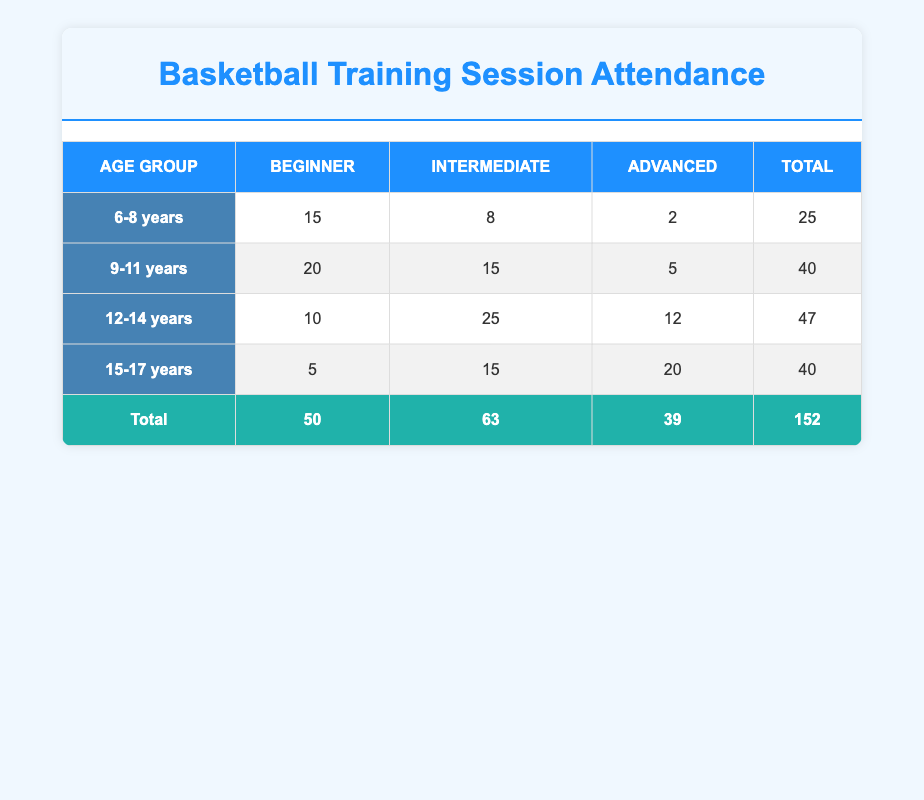What is the total attendance for the 12-14 years age group? The total attendance for the 12-14 years age group can be found in the last column of this row. The values for Beginner, Intermediate, and Advanced are 10, 25, and 12 respectively. Adding these values together, 10 + 25 + 12 gives us a total of 47.
Answer: 47 How many more attendees participated in the Intermediate skill level compared to the Beginner skill level in the 9-11 years age group? For the 9-11 years age group, the Intermediate skill level has 15 attendees, while the Beginner skill level has 20 attendees. To find out how many more attended Intermediate than Beginner, subtract the Beginners from the Intermediates: 15 - 20 equals -5. This means there are 5 fewer attendees in Intermediate compared to Beginner.
Answer: 5 fewer attendees Is there more total attendance in the age group 6-8 years compared to 15-17 years? The total attendance for these age groups must be compared. The total attendance for 6-8 years is 25 (15+8+2) and for 15-17 years is 40 (5+15+20). Since 25 is less than 40, the answer is no, 6-8 years does not have more attendees.
Answer: No What is the total attendance across all age groups for the Advanced skill level? To find the total attendance for the Advanced skill level, I need to sum the values in the Advanced column for each age group: 2 (6-8 years) + 5 (9-11 years) + 12 (12-14 years) + 20 (15-17 years) equals 39. Therefore, the total attendance for the Advanced skill level is 39.
Answer: 39 Which age group has the highest attendance among all skill levels combined? To find the age group with the highest total attendance, I will sum the attendance for each age group: 6-8 years totals 25, 9-11 years totals 40, 12-14 years totals 47, and 15-17 years totals 40. The highest total is 47 in the 12-14 years age group.
Answer: 12-14 years 